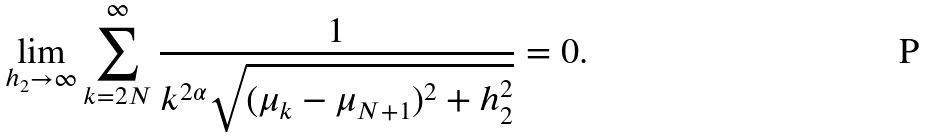Convert formula to latex. <formula><loc_0><loc_0><loc_500><loc_500>\lim _ { h _ { 2 } \to \infty } \sum _ { k = 2 N } ^ { \infty } \frac { 1 } { k ^ { 2 \alpha } \sqrt { ( \mu _ { k } - \mu _ { N + 1 } ) ^ { 2 } + h _ { 2 } ^ { 2 } } } = 0 .</formula> 